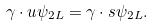<formula> <loc_0><loc_0><loc_500><loc_500>\gamma \cdot u \psi _ { 2 L } = \gamma \cdot s \psi _ { 2 L } .</formula> 